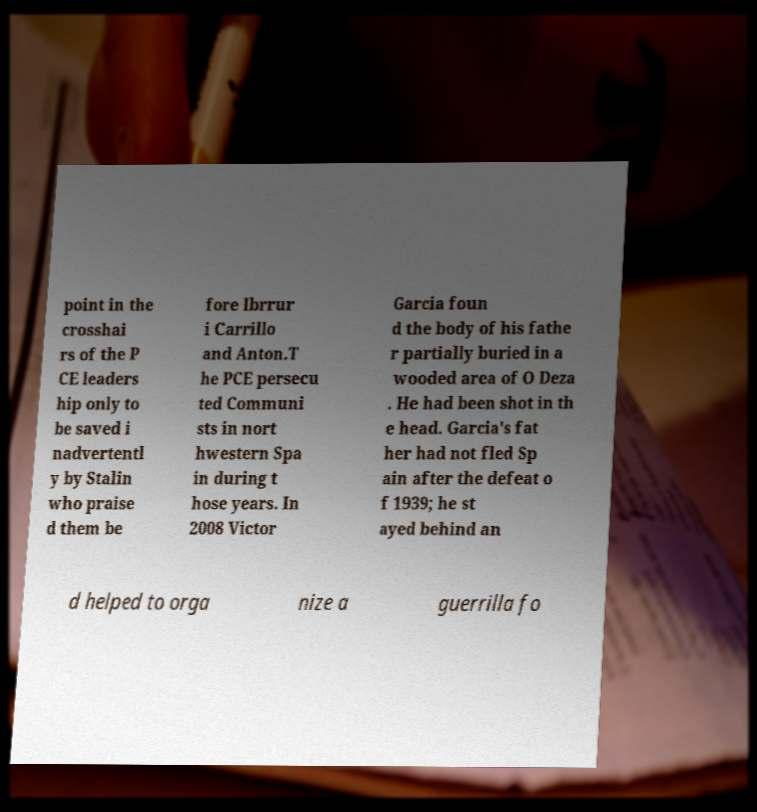Can you read and provide the text displayed in the image?This photo seems to have some interesting text. Can you extract and type it out for me? point in the crosshai rs of the P CE leaders hip only to be saved i nadvertentl y by Stalin who praise d them be fore Ibrrur i Carrillo and Anton.T he PCE persecu ted Communi sts in nort hwestern Spa in during t hose years. In 2008 Victor Garcia foun d the body of his fathe r partially buried in a wooded area of O Deza . He had been shot in th e head. Garcia's fat her had not fled Sp ain after the defeat o f 1939; he st ayed behind an d helped to orga nize a guerrilla fo 